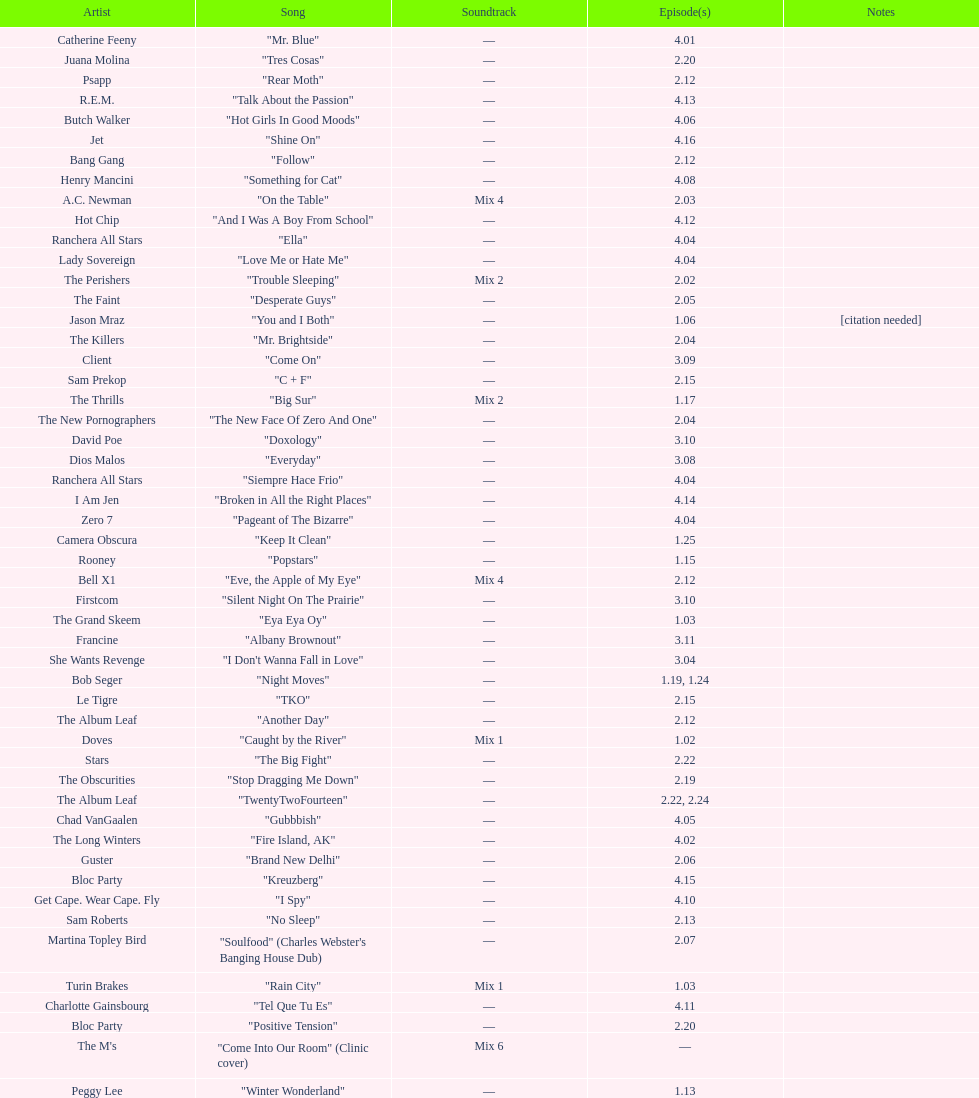What artist has more music appear in the show, daft punk or franz ferdinand? Franz Ferdinand. 